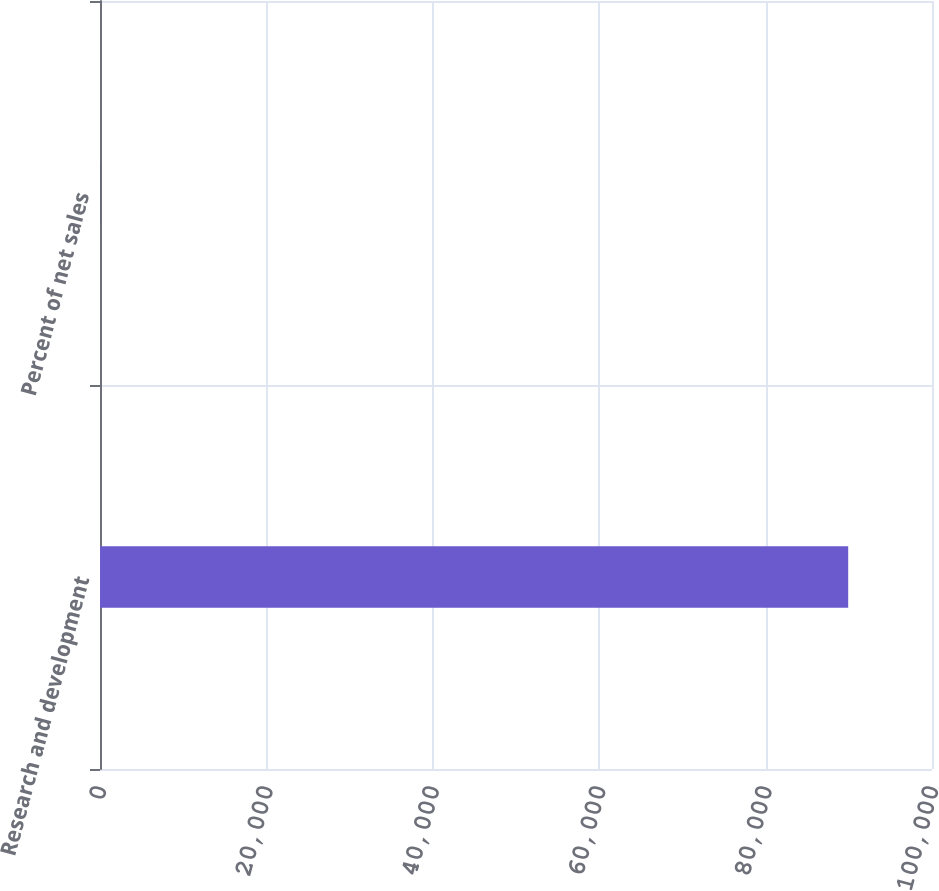Convert chart. <chart><loc_0><loc_0><loc_500><loc_500><bar_chart><fcel>Research and development<fcel>Percent of net sales<nl><fcel>89926<fcel>9.1<nl></chart> 